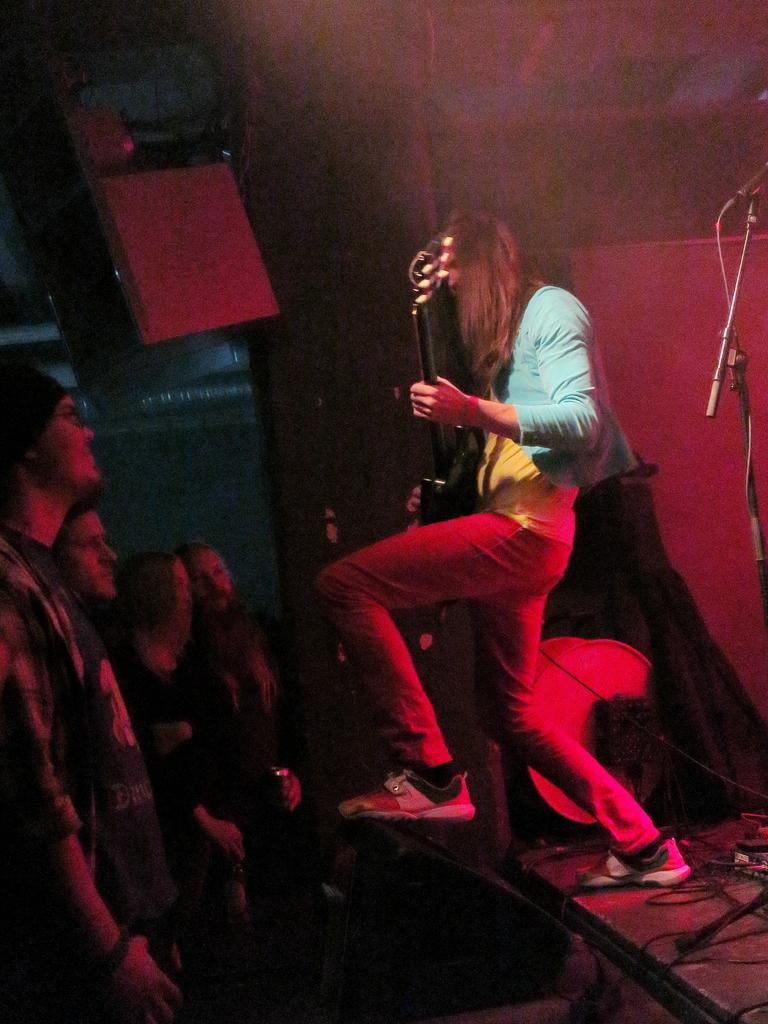What is the person in the image doing? The person in the image is playing a guitar. Where is the person playing the guitar located? The person is on a stage. Who is present in front of the stage? There is an audience in front of the stage. What is the audience doing in the image? The audience is looking at the person playing the guitar. What type of chin is visible on the guitar in the image? There is no chin visible on the guitar in the image, as guitars do not have chins. 